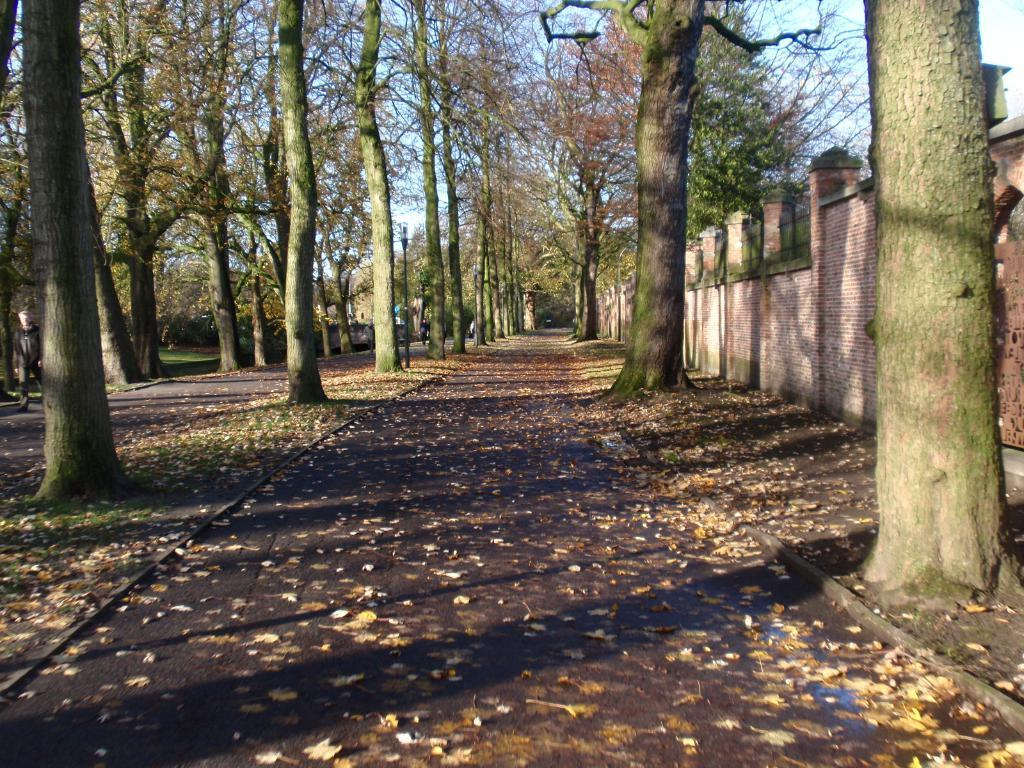What type of vegetation can be seen in the image? There are trees in the image. What structure is visible in the image? There is a wall in the image. What is the man in the image doing? A man is walking on the road in the image. What object can be seen standing upright in the image? There is a pole in the image. What type of clouds can be seen in the image? There are no clouds visible in the image. What is the man holding in his hand in the image? The provided facts do not mention any bottle or object being held by the man, so we cannot determine what he might be holding. 